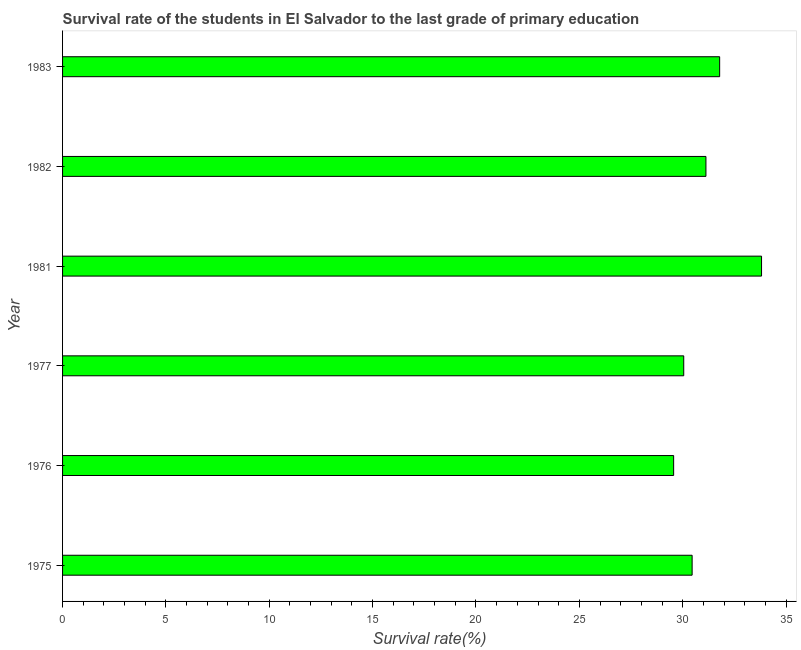What is the title of the graph?
Keep it short and to the point. Survival rate of the students in El Salvador to the last grade of primary education. What is the label or title of the X-axis?
Offer a very short reply. Survival rate(%). What is the label or title of the Y-axis?
Keep it short and to the point. Year. What is the survival rate in primary education in 1975?
Provide a succinct answer. 30.46. Across all years, what is the maximum survival rate in primary education?
Your response must be concise. 33.81. Across all years, what is the minimum survival rate in primary education?
Provide a short and direct response. 29.56. In which year was the survival rate in primary education maximum?
Provide a short and direct response. 1981. In which year was the survival rate in primary education minimum?
Keep it short and to the point. 1976. What is the sum of the survival rate in primary education?
Give a very brief answer. 186.8. What is the difference between the survival rate in primary education in 1975 and 1982?
Your answer should be very brief. -0.67. What is the average survival rate in primary education per year?
Give a very brief answer. 31.13. What is the median survival rate in primary education?
Your answer should be very brief. 30.79. In how many years, is the survival rate in primary education greater than 3 %?
Your response must be concise. 6. Do a majority of the years between 1977 and 1983 (inclusive) have survival rate in primary education greater than 7 %?
Offer a terse response. Yes. What is the ratio of the survival rate in primary education in 1976 to that in 1983?
Provide a succinct answer. 0.93. What is the difference between the highest and the second highest survival rate in primary education?
Provide a succinct answer. 2.03. Is the sum of the survival rate in primary education in 1981 and 1983 greater than the maximum survival rate in primary education across all years?
Ensure brevity in your answer.  Yes. What is the difference between the highest and the lowest survival rate in primary education?
Make the answer very short. 4.25. How many years are there in the graph?
Your answer should be very brief. 6. What is the difference between two consecutive major ticks on the X-axis?
Provide a short and direct response. 5. Are the values on the major ticks of X-axis written in scientific E-notation?
Offer a very short reply. No. What is the Survival rate(%) in 1975?
Make the answer very short. 30.46. What is the Survival rate(%) of 1976?
Provide a short and direct response. 29.56. What is the Survival rate(%) in 1977?
Keep it short and to the point. 30.05. What is the Survival rate(%) of 1981?
Provide a short and direct response. 33.81. What is the Survival rate(%) in 1982?
Offer a terse response. 31.12. What is the Survival rate(%) of 1983?
Make the answer very short. 31.79. What is the difference between the Survival rate(%) in 1975 and 1976?
Keep it short and to the point. 0.89. What is the difference between the Survival rate(%) in 1975 and 1977?
Keep it short and to the point. 0.41. What is the difference between the Survival rate(%) in 1975 and 1981?
Provide a succinct answer. -3.36. What is the difference between the Survival rate(%) in 1975 and 1982?
Offer a terse response. -0.67. What is the difference between the Survival rate(%) in 1975 and 1983?
Your answer should be very brief. -1.33. What is the difference between the Survival rate(%) in 1976 and 1977?
Give a very brief answer. -0.49. What is the difference between the Survival rate(%) in 1976 and 1981?
Ensure brevity in your answer.  -4.25. What is the difference between the Survival rate(%) in 1976 and 1982?
Your response must be concise. -1.56. What is the difference between the Survival rate(%) in 1976 and 1983?
Offer a terse response. -2.23. What is the difference between the Survival rate(%) in 1977 and 1981?
Keep it short and to the point. -3.76. What is the difference between the Survival rate(%) in 1977 and 1982?
Provide a short and direct response. -1.07. What is the difference between the Survival rate(%) in 1977 and 1983?
Ensure brevity in your answer.  -1.74. What is the difference between the Survival rate(%) in 1981 and 1982?
Provide a short and direct response. 2.69. What is the difference between the Survival rate(%) in 1981 and 1983?
Keep it short and to the point. 2.03. What is the difference between the Survival rate(%) in 1982 and 1983?
Offer a very short reply. -0.66. What is the ratio of the Survival rate(%) in 1975 to that in 1981?
Your answer should be compact. 0.9. What is the ratio of the Survival rate(%) in 1975 to that in 1982?
Keep it short and to the point. 0.98. What is the ratio of the Survival rate(%) in 1975 to that in 1983?
Ensure brevity in your answer.  0.96. What is the ratio of the Survival rate(%) in 1976 to that in 1981?
Your response must be concise. 0.87. What is the ratio of the Survival rate(%) in 1976 to that in 1983?
Give a very brief answer. 0.93. What is the ratio of the Survival rate(%) in 1977 to that in 1981?
Your answer should be very brief. 0.89. What is the ratio of the Survival rate(%) in 1977 to that in 1983?
Ensure brevity in your answer.  0.94. What is the ratio of the Survival rate(%) in 1981 to that in 1982?
Your response must be concise. 1.09. What is the ratio of the Survival rate(%) in 1981 to that in 1983?
Your answer should be compact. 1.06. 